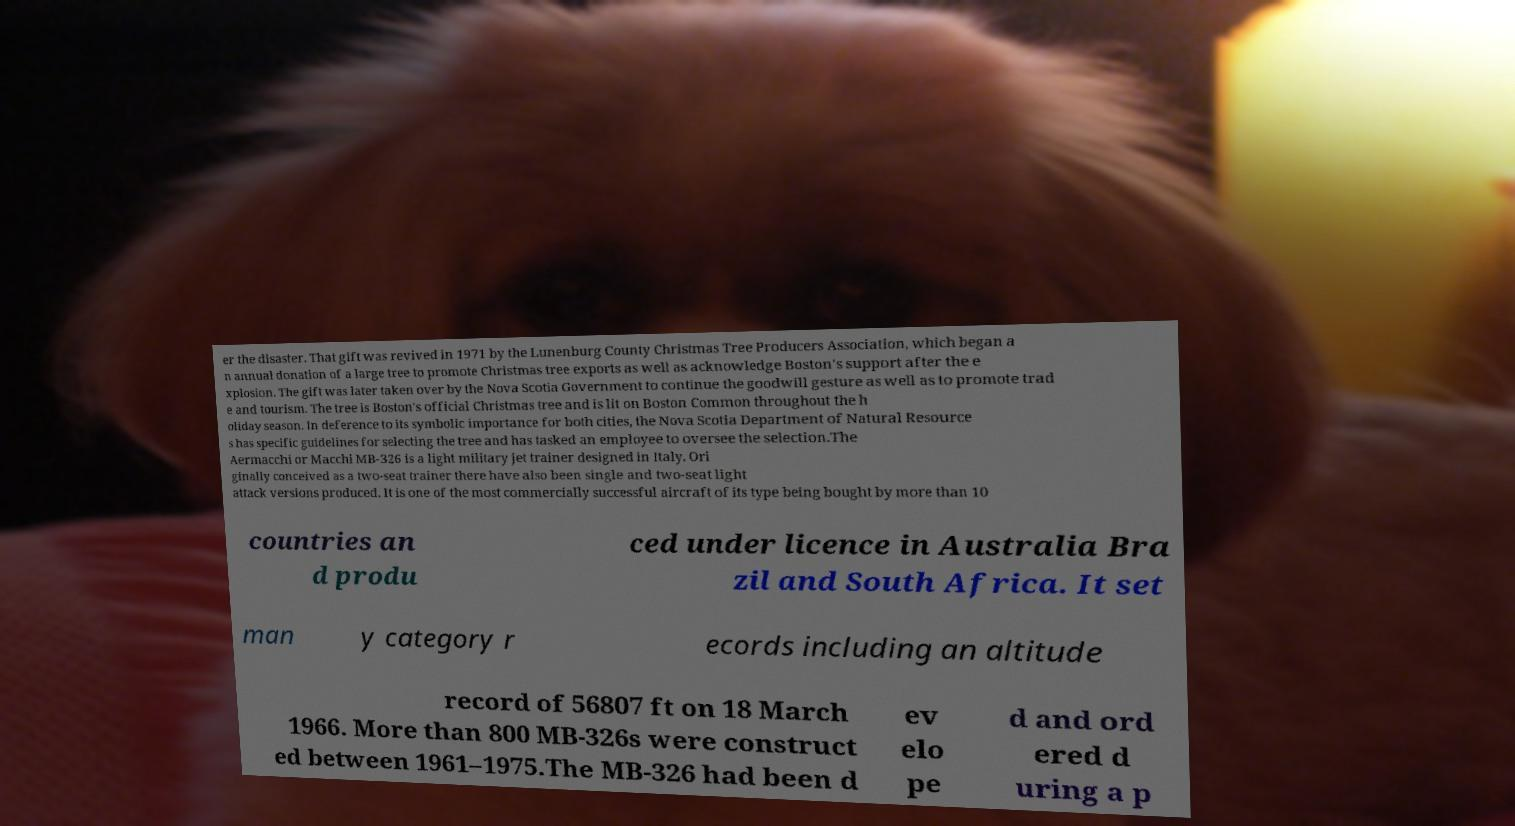For documentation purposes, I need the text within this image transcribed. Could you provide that? er the disaster. That gift was revived in 1971 by the Lunenburg County Christmas Tree Producers Association, which began a n annual donation of a large tree to promote Christmas tree exports as well as acknowledge Boston's support after the e xplosion. The gift was later taken over by the Nova Scotia Government to continue the goodwill gesture as well as to promote trad e and tourism. The tree is Boston's official Christmas tree and is lit on Boston Common throughout the h oliday season. In deference to its symbolic importance for both cities, the Nova Scotia Department of Natural Resource s has specific guidelines for selecting the tree and has tasked an employee to oversee the selection.The Aermacchi or Macchi MB-326 is a light military jet trainer designed in Italy. Ori ginally conceived as a two-seat trainer there have also been single and two-seat light attack versions produced. It is one of the most commercially successful aircraft of its type being bought by more than 10 countries an d produ ced under licence in Australia Bra zil and South Africa. It set man y category r ecords including an altitude record of 56807 ft on 18 March 1966. More than 800 MB-326s were construct ed between 1961–1975.The MB-326 had been d ev elo pe d and ord ered d uring a p 